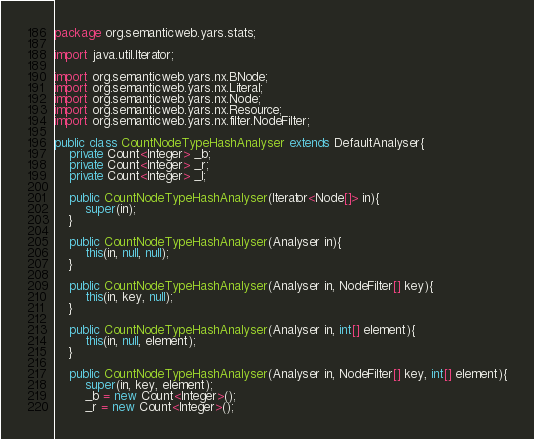<code> <loc_0><loc_0><loc_500><loc_500><_Java_>package org.semanticweb.yars.stats;

import java.util.Iterator;

import org.semanticweb.yars.nx.BNode;
import org.semanticweb.yars.nx.Literal;
import org.semanticweb.yars.nx.Node;
import org.semanticweb.yars.nx.Resource;
import org.semanticweb.yars.nx.filter.NodeFilter;

public class CountNodeTypeHashAnalyser extends DefaultAnalyser{
	private Count<Integer> _b;
	private Count<Integer> _r;
	private Count<Integer> _l;
	
	public CountNodeTypeHashAnalyser(Iterator<Node[]> in){
		super(in);
	}
	
	public CountNodeTypeHashAnalyser(Analyser in){
		this(in, null, null);
	}
	
	public CountNodeTypeHashAnalyser(Analyser in, NodeFilter[] key){
		this(in, key, null);
	}
	
	public CountNodeTypeHashAnalyser(Analyser in, int[] element){
		this(in, null, element);
	}
	
	public CountNodeTypeHashAnalyser(Analyser in, NodeFilter[] key, int[] element){
		super(in, key, element);
		_b = new Count<Integer>();
		_r = new Count<Integer>();</code> 